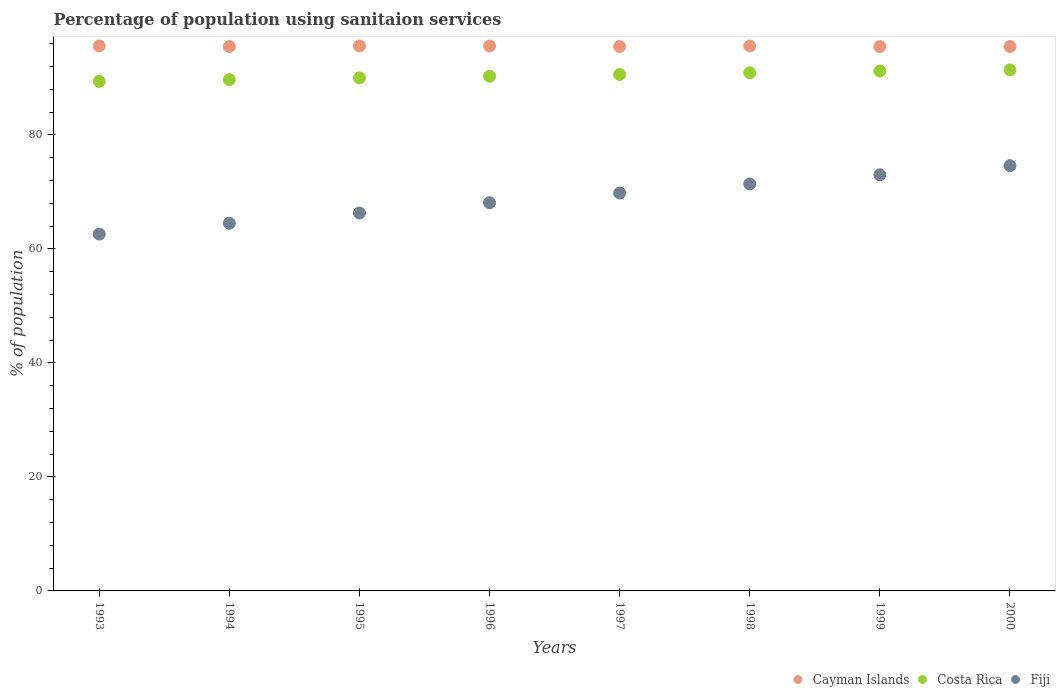Is the number of dotlines equal to the number of legend labels?
Keep it short and to the point. Yes. What is the percentage of population using sanitaion services in Cayman Islands in 1997?
Give a very brief answer. 95.5. Across all years, what is the maximum percentage of population using sanitaion services in Costa Rica?
Give a very brief answer. 91.4. Across all years, what is the minimum percentage of population using sanitaion services in Cayman Islands?
Keep it short and to the point. 95.5. In which year was the percentage of population using sanitaion services in Cayman Islands maximum?
Give a very brief answer. 1993. In which year was the percentage of population using sanitaion services in Fiji minimum?
Make the answer very short. 1993. What is the total percentage of population using sanitaion services in Fiji in the graph?
Your response must be concise. 550.3. What is the difference between the percentage of population using sanitaion services in Cayman Islands in 1996 and that in 1997?
Provide a succinct answer. 0.1. What is the difference between the percentage of population using sanitaion services in Fiji in 1993 and the percentage of population using sanitaion services in Cayman Islands in 1995?
Give a very brief answer. -33. What is the average percentage of population using sanitaion services in Costa Rica per year?
Provide a succinct answer. 90.44. In the year 1993, what is the difference between the percentage of population using sanitaion services in Cayman Islands and percentage of population using sanitaion services in Costa Rica?
Offer a terse response. 6.2. What is the ratio of the percentage of population using sanitaion services in Cayman Islands in 1995 to that in 1997?
Provide a short and direct response. 1. Is the percentage of population using sanitaion services in Cayman Islands in 1993 less than that in 1995?
Give a very brief answer. No. What is the difference between the highest and the second highest percentage of population using sanitaion services in Fiji?
Make the answer very short. 1.6. What is the difference between the highest and the lowest percentage of population using sanitaion services in Fiji?
Your answer should be very brief. 12. Is the sum of the percentage of population using sanitaion services in Cayman Islands in 1993 and 1996 greater than the maximum percentage of population using sanitaion services in Fiji across all years?
Ensure brevity in your answer.  Yes. Is the percentage of population using sanitaion services in Cayman Islands strictly less than the percentage of population using sanitaion services in Fiji over the years?
Give a very brief answer. No. How many dotlines are there?
Offer a terse response. 3. What is the difference between two consecutive major ticks on the Y-axis?
Provide a succinct answer. 20. Does the graph contain any zero values?
Your response must be concise. No. Does the graph contain grids?
Provide a succinct answer. No. Where does the legend appear in the graph?
Your response must be concise. Bottom right. How many legend labels are there?
Offer a very short reply. 3. What is the title of the graph?
Offer a terse response. Percentage of population using sanitaion services. What is the label or title of the Y-axis?
Keep it short and to the point. % of population. What is the % of population in Cayman Islands in 1993?
Offer a terse response. 95.6. What is the % of population in Costa Rica in 1993?
Your answer should be compact. 89.4. What is the % of population in Fiji in 1993?
Offer a terse response. 62.6. What is the % of population of Cayman Islands in 1994?
Make the answer very short. 95.5. What is the % of population in Costa Rica in 1994?
Provide a short and direct response. 89.7. What is the % of population of Fiji in 1994?
Make the answer very short. 64.5. What is the % of population in Cayman Islands in 1995?
Your answer should be compact. 95.6. What is the % of population in Fiji in 1995?
Keep it short and to the point. 66.3. What is the % of population in Cayman Islands in 1996?
Make the answer very short. 95.6. What is the % of population of Costa Rica in 1996?
Give a very brief answer. 90.3. What is the % of population of Fiji in 1996?
Offer a terse response. 68.1. What is the % of population of Cayman Islands in 1997?
Offer a very short reply. 95.5. What is the % of population in Costa Rica in 1997?
Your response must be concise. 90.6. What is the % of population of Fiji in 1997?
Provide a succinct answer. 69.8. What is the % of population of Cayman Islands in 1998?
Make the answer very short. 95.6. What is the % of population of Costa Rica in 1998?
Offer a terse response. 90.9. What is the % of population in Fiji in 1998?
Offer a very short reply. 71.4. What is the % of population of Cayman Islands in 1999?
Your response must be concise. 95.5. What is the % of population in Costa Rica in 1999?
Your answer should be compact. 91.2. What is the % of population in Cayman Islands in 2000?
Offer a very short reply. 95.5. What is the % of population in Costa Rica in 2000?
Your answer should be very brief. 91.4. What is the % of population in Fiji in 2000?
Provide a succinct answer. 74.6. Across all years, what is the maximum % of population of Cayman Islands?
Provide a succinct answer. 95.6. Across all years, what is the maximum % of population of Costa Rica?
Your answer should be compact. 91.4. Across all years, what is the maximum % of population of Fiji?
Provide a succinct answer. 74.6. Across all years, what is the minimum % of population in Cayman Islands?
Your response must be concise. 95.5. Across all years, what is the minimum % of population of Costa Rica?
Keep it short and to the point. 89.4. Across all years, what is the minimum % of population in Fiji?
Ensure brevity in your answer.  62.6. What is the total % of population in Cayman Islands in the graph?
Give a very brief answer. 764.4. What is the total % of population in Costa Rica in the graph?
Provide a succinct answer. 723.5. What is the total % of population of Fiji in the graph?
Offer a terse response. 550.3. What is the difference between the % of population in Cayman Islands in 1993 and that in 1994?
Make the answer very short. 0.1. What is the difference between the % of population of Costa Rica in 1993 and that in 1995?
Your response must be concise. -0.6. What is the difference between the % of population in Cayman Islands in 1993 and that in 1996?
Keep it short and to the point. 0. What is the difference between the % of population of Cayman Islands in 1993 and that in 1997?
Give a very brief answer. 0.1. What is the difference between the % of population of Cayman Islands in 1993 and that in 1998?
Offer a terse response. 0. What is the difference between the % of population of Fiji in 1993 and that in 1998?
Offer a very short reply. -8.8. What is the difference between the % of population in Fiji in 1993 and that in 1999?
Provide a short and direct response. -10.4. What is the difference between the % of population of Fiji in 1993 and that in 2000?
Offer a very short reply. -12. What is the difference between the % of population in Costa Rica in 1994 and that in 1995?
Offer a terse response. -0.3. What is the difference between the % of population of Cayman Islands in 1994 and that in 1996?
Keep it short and to the point. -0.1. What is the difference between the % of population in Fiji in 1994 and that in 1996?
Your response must be concise. -3.6. What is the difference between the % of population of Costa Rica in 1994 and that in 1997?
Ensure brevity in your answer.  -0.9. What is the difference between the % of population in Fiji in 1994 and that in 1997?
Your answer should be very brief. -5.3. What is the difference between the % of population in Cayman Islands in 1994 and that in 1998?
Give a very brief answer. -0.1. What is the difference between the % of population in Costa Rica in 1994 and that in 1998?
Provide a short and direct response. -1.2. What is the difference between the % of population in Fiji in 1994 and that in 1998?
Your answer should be compact. -6.9. What is the difference between the % of population of Cayman Islands in 1994 and that in 1999?
Keep it short and to the point. 0. What is the difference between the % of population in Costa Rica in 1994 and that in 1999?
Make the answer very short. -1.5. What is the difference between the % of population in Fiji in 1994 and that in 1999?
Your answer should be very brief. -8.5. What is the difference between the % of population of Cayman Islands in 1994 and that in 2000?
Offer a terse response. 0. What is the difference between the % of population of Fiji in 1994 and that in 2000?
Your answer should be very brief. -10.1. What is the difference between the % of population of Cayman Islands in 1995 and that in 1996?
Ensure brevity in your answer.  0. What is the difference between the % of population in Costa Rica in 1995 and that in 1996?
Make the answer very short. -0.3. What is the difference between the % of population in Fiji in 1995 and that in 1996?
Offer a very short reply. -1.8. What is the difference between the % of population of Cayman Islands in 1995 and that in 1997?
Give a very brief answer. 0.1. What is the difference between the % of population in Costa Rica in 1995 and that in 1998?
Offer a terse response. -0.9. What is the difference between the % of population in Fiji in 1995 and that in 1998?
Offer a very short reply. -5.1. What is the difference between the % of population in Cayman Islands in 1995 and that in 1999?
Provide a succinct answer. 0.1. What is the difference between the % of population of Costa Rica in 1995 and that in 1999?
Keep it short and to the point. -1.2. What is the difference between the % of population of Cayman Islands in 1995 and that in 2000?
Provide a short and direct response. 0.1. What is the difference between the % of population in Costa Rica in 1995 and that in 2000?
Provide a short and direct response. -1.4. What is the difference between the % of population of Cayman Islands in 1996 and that in 1997?
Your response must be concise. 0.1. What is the difference between the % of population of Fiji in 1996 and that in 1997?
Offer a terse response. -1.7. What is the difference between the % of population in Cayman Islands in 1996 and that in 1998?
Your answer should be very brief. 0. What is the difference between the % of population in Costa Rica in 1996 and that in 1998?
Your answer should be very brief. -0.6. What is the difference between the % of population of Costa Rica in 1996 and that in 1999?
Your answer should be compact. -0.9. What is the difference between the % of population of Fiji in 1996 and that in 1999?
Give a very brief answer. -4.9. What is the difference between the % of population in Fiji in 1996 and that in 2000?
Make the answer very short. -6.5. What is the difference between the % of population of Costa Rica in 1997 and that in 1998?
Provide a succinct answer. -0.3. What is the difference between the % of population of Fiji in 1997 and that in 1998?
Your answer should be very brief. -1.6. What is the difference between the % of population of Costa Rica in 1997 and that in 1999?
Provide a succinct answer. -0.6. What is the difference between the % of population in Fiji in 1997 and that in 1999?
Your answer should be very brief. -3.2. What is the difference between the % of population of Costa Rica in 1997 and that in 2000?
Your answer should be very brief. -0.8. What is the difference between the % of population in Fiji in 1997 and that in 2000?
Provide a short and direct response. -4.8. What is the difference between the % of population in Cayman Islands in 1998 and that in 2000?
Provide a succinct answer. 0.1. What is the difference between the % of population in Costa Rica in 1998 and that in 2000?
Make the answer very short. -0.5. What is the difference between the % of population of Costa Rica in 1999 and that in 2000?
Provide a short and direct response. -0.2. What is the difference between the % of population in Cayman Islands in 1993 and the % of population in Fiji in 1994?
Make the answer very short. 31.1. What is the difference between the % of population in Costa Rica in 1993 and the % of population in Fiji in 1994?
Offer a terse response. 24.9. What is the difference between the % of population of Cayman Islands in 1993 and the % of population of Costa Rica in 1995?
Your response must be concise. 5.6. What is the difference between the % of population of Cayman Islands in 1993 and the % of population of Fiji in 1995?
Make the answer very short. 29.3. What is the difference between the % of population in Costa Rica in 1993 and the % of population in Fiji in 1995?
Your answer should be compact. 23.1. What is the difference between the % of population of Costa Rica in 1993 and the % of population of Fiji in 1996?
Ensure brevity in your answer.  21.3. What is the difference between the % of population in Cayman Islands in 1993 and the % of population in Fiji in 1997?
Provide a short and direct response. 25.8. What is the difference between the % of population of Costa Rica in 1993 and the % of population of Fiji in 1997?
Give a very brief answer. 19.6. What is the difference between the % of population in Cayman Islands in 1993 and the % of population in Costa Rica in 1998?
Provide a short and direct response. 4.7. What is the difference between the % of population of Cayman Islands in 1993 and the % of population of Fiji in 1998?
Keep it short and to the point. 24.2. What is the difference between the % of population of Cayman Islands in 1993 and the % of population of Fiji in 1999?
Your response must be concise. 22.6. What is the difference between the % of population in Cayman Islands in 1993 and the % of population in Costa Rica in 2000?
Offer a very short reply. 4.2. What is the difference between the % of population of Cayman Islands in 1994 and the % of population of Fiji in 1995?
Give a very brief answer. 29.2. What is the difference between the % of population of Costa Rica in 1994 and the % of population of Fiji in 1995?
Offer a terse response. 23.4. What is the difference between the % of population in Cayman Islands in 1994 and the % of population in Fiji in 1996?
Provide a succinct answer. 27.4. What is the difference between the % of population in Costa Rica in 1994 and the % of population in Fiji in 1996?
Your answer should be compact. 21.6. What is the difference between the % of population of Cayman Islands in 1994 and the % of population of Costa Rica in 1997?
Your answer should be very brief. 4.9. What is the difference between the % of population of Cayman Islands in 1994 and the % of population of Fiji in 1997?
Offer a terse response. 25.7. What is the difference between the % of population in Costa Rica in 1994 and the % of population in Fiji in 1997?
Your answer should be very brief. 19.9. What is the difference between the % of population of Cayman Islands in 1994 and the % of population of Costa Rica in 1998?
Your answer should be very brief. 4.6. What is the difference between the % of population of Cayman Islands in 1994 and the % of population of Fiji in 1998?
Ensure brevity in your answer.  24.1. What is the difference between the % of population of Cayman Islands in 1994 and the % of population of Costa Rica in 1999?
Give a very brief answer. 4.3. What is the difference between the % of population in Cayman Islands in 1994 and the % of population in Fiji in 1999?
Offer a very short reply. 22.5. What is the difference between the % of population in Costa Rica in 1994 and the % of population in Fiji in 1999?
Make the answer very short. 16.7. What is the difference between the % of population in Cayman Islands in 1994 and the % of population in Costa Rica in 2000?
Provide a short and direct response. 4.1. What is the difference between the % of population of Cayman Islands in 1994 and the % of population of Fiji in 2000?
Provide a succinct answer. 20.9. What is the difference between the % of population of Cayman Islands in 1995 and the % of population of Fiji in 1996?
Your answer should be compact. 27.5. What is the difference between the % of population in Costa Rica in 1995 and the % of population in Fiji in 1996?
Ensure brevity in your answer.  21.9. What is the difference between the % of population of Cayman Islands in 1995 and the % of population of Costa Rica in 1997?
Provide a short and direct response. 5. What is the difference between the % of population of Cayman Islands in 1995 and the % of population of Fiji in 1997?
Make the answer very short. 25.8. What is the difference between the % of population of Costa Rica in 1995 and the % of population of Fiji in 1997?
Provide a succinct answer. 20.2. What is the difference between the % of population in Cayman Islands in 1995 and the % of population in Fiji in 1998?
Give a very brief answer. 24.2. What is the difference between the % of population in Costa Rica in 1995 and the % of population in Fiji in 1998?
Make the answer very short. 18.6. What is the difference between the % of population of Cayman Islands in 1995 and the % of population of Fiji in 1999?
Keep it short and to the point. 22.6. What is the difference between the % of population in Costa Rica in 1995 and the % of population in Fiji in 2000?
Your answer should be compact. 15.4. What is the difference between the % of population of Cayman Islands in 1996 and the % of population of Costa Rica in 1997?
Give a very brief answer. 5. What is the difference between the % of population in Cayman Islands in 1996 and the % of population in Fiji in 1997?
Give a very brief answer. 25.8. What is the difference between the % of population of Costa Rica in 1996 and the % of population of Fiji in 1997?
Offer a very short reply. 20.5. What is the difference between the % of population of Cayman Islands in 1996 and the % of population of Fiji in 1998?
Give a very brief answer. 24.2. What is the difference between the % of population in Costa Rica in 1996 and the % of population in Fiji in 1998?
Your answer should be very brief. 18.9. What is the difference between the % of population of Cayman Islands in 1996 and the % of population of Costa Rica in 1999?
Offer a terse response. 4.4. What is the difference between the % of population of Cayman Islands in 1996 and the % of population of Fiji in 1999?
Offer a very short reply. 22.6. What is the difference between the % of population in Costa Rica in 1996 and the % of population in Fiji in 1999?
Your answer should be very brief. 17.3. What is the difference between the % of population in Cayman Islands in 1996 and the % of population in Costa Rica in 2000?
Provide a short and direct response. 4.2. What is the difference between the % of population in Costa Rica in 1996 and the % of population in Fiji in 2000?
Offer a terse response. 15.7. What is the difference between the % of population of Cayman Islands in 1997 and the % of population of Fiji in 1998?
Keep it short and to the point. 24.1. What is the difference between the % of population of Costa Rica in 1997 and the % of population of Fiji in 1998?
Your answer should be compact. 19.2. What is the difference between the % of population in Cayman Islands in 1997 and the % of population in Costa Rica in 1999?
Your answer should be compact. 4.3. What is the difference between the % of population of Costa Rica in 1997 and the % of population of Fiji in 1999?
Your response must be concise. 17.6. What is the difference between the % of population in Cayman Islands in 1997 and the % of population in Costa Rica in 2000?
Provide a succinct answer. 4.1. What is the difference between the % of population in Cayman Islands in 1997 and the % of population in Fiji in 2000?
Your response must be concise. 20.9. What is the difference between the % of population in Costa Rica in 1997 and the % of population in Fiji in 2000?
Provide a succinct answer. 16. What is the difference between the % of population of Cayman Islands in 1998 and the % of population of Fiji in 1999?
Offer a terse response. 22.6. What is the difference between the % of population of Costa Rica in 1998 and the % of population of Fiji in 1999?
Your response must be concise. 17.9. What is the difference between the % of population of Cayman Islands in 1998 and the % of population of Costa Rica in 2000?
Ensure brevity in your answer.  4.2. What is the difference between the % of population in Cayman Islands in 1998 and the % of population in Fiji in 2000?
Provide a short and direct response. 21. What is the difference between the % of population in Cayman Islands in 1999 and the % of population in Fiji in 2000?
Your answer should be very brief. 20.9. What is the average % of population in Cayman Islands per year?
Keep it short and to the point. 95.55. What is the average % of population in Costa Rica per year?
Your answer should be very brief. 90.44. What is the average % of population of Fiji per year?
Your answer should be very brief. 68.79. In the year 1993, what is the difference between the % of population of Costa Rica and % of population of Fiji?
Provide a short and direct response. 26.8. In the year 1994, what is the difference between the % of population of Costa Rica and % of population of Fiji?
Make the answer very short. 25.2. In the year 1995, what is the difference between the % of population of Cayman Islands and % of population of Fiji?
Offer a terse response. 29.3. In the year 1995, what is the difference between the % of population in Costa Rica and % of population in Fiji?
Your answer should be compact. 23.7. In the year 1996, what is the difference between the % of population in Cayman Islands and % of population in Fiji?
Offer a very short reply. 27.5. In the year 1997, what is the difference between the % of population of Cayman Islands and % of population of Fiji?
Your response must be concise. 25.7. In the year 1997, what is the difference between the % of population of Costa Rica and % of population of Fiji?
Provide a succinct answer. 20.8. In the year 1998, what is the difference between the % of population of Cayman Islands and % of population of Fiji?
Provide a succinct answer. 24.2. In the year 1998, what is the difference between the % of population in Costa Rica and % of population in Fiji?
Your answer should be compact. 19.5. In the year 2000, what is the difference between the % of population in Cayman Islands and % of population in Fiji?
Keep it short and to the point. 20.9. In the year 2000, what is the difference between the % of population of Costa Rica and % of population of Fiji?
Keep it short and to the point. 16.8. What is the ratio of the % of population of Cayman Islands in 1993 to that in 1994?
Keep it short and to the point. 1. What is the ratio of the % of population of Costa Rica in 1993 to that in 1994?
Ensure brevity in your answer.  1. What is the ratio of the % of population in Fiji in 1993 to that in 1994?
Provide a short and direct response. 0.97. What is the ratio of the % of population in Cayman Islands in 1993 to that in 1995?
Keep it short and to the point. 1. What is the ratio of the % of population in Fiji in 1993 to that in 1995?
Your answer should be very brief. 0.94. What is the ratio of the % of population of Costa Rica in 1993 to that in 1996?
Your answer should be very brief. 0.99. What is the ratio of the % of population in Fiji in 1993 to that in 1996?
Provide a succinct answer. 0.92. What is the ratio of the % of population of Cayman Islands in 1993 to that in 1997?
Ensure brevity in your answer.  1. What is the ratio of the % of population in Fiji in 1993 to that in 1997?
Your answer should be very brief. 0.9. What is the ratio of the % of population of Costa Rica in 1993 to that in 1998?
Your answer should be compact. 0.98. What is the ratio of the % of population in Fiji in 1993 to that in 1998?
Make the answer very short. 0.88. What is the ratio of the % of population of Costa Rica in 1993 to that in 1999?
Offer a very short reply. 0.98. What is the ratio of the % of population of Fiji in 1993 to that in 1999?
Provide a succinct answer. 0.86. What is the ratio of the % of population in Cayman Islands in 1993 to that in 2000?
Keep it short and to the point. 1. What is the ratio of the % of population in Costa Rica in 1993 to that in 2000?
Your answer should be very brief. 0.98. What is the ratio of the % of population in Fiji in 1993 to that in 2000?
Offer a very short reply. 0.84. What is the ratio of the % of population of Costa Rica in 1994 to that in 1995?
Provide a short and direct response. 1. What is the ratio of the % of population of Fiji in 1994 to that in 1995?
Offer a terse response. 0.97. What is the ratio of the % of population in Costa Rica in 1994 to that in 1996?
Your response must be concise. 0.99. What is the ratio of the % of population of Fiji in 1994 to that in 1996?
Make the answer very short. 0.95. What is the ratio of the % of population in Fiji in 1994 to that in 1997?
Your response must be concise. 0.92. What is the ratio of the % of population of Cayman Islands in 1994 to that in 1998?
Your response must be concise. 1. What is the ratio of the % of population of Costa Rica in 1994 to that in 1998?
Make the answer very short. 0.99. What is the ratio of the % of population of Fiji in 1994 to that in 1998?
Keep it short and to the point. 0.9. What is the ratio of the % of population of Costa Rica in 1994 to that in 1999?
Give a very brief answer. 0.98. What is the ratio of the % of population of Fiji in 1994 to that in 1999?
Provide a short and direct response. 0.88. What is the ratio of the % of population in Costa Rica in 1994 to that in 2000?
Make the answer very short. 0.98. What is the ratio of the % of population in Fiji in 1994 to that in 2000?
Provide a succinct answer. 0.86. What is the ratio of the % of population in Cayman Islands in 1995 to that in 1996?
Provide a short and direct response. 1. What is the ratio of the % of population in Costa Rica in 1995 to that in 1996?
Make the answer very short. 1. What is the ratio of the % of population of Fiji in 1995 to that in 1996?
Your response must be concise. 0.97. What is the ratio of the % of population in Cayman Islands in 1995 to that in 1997?
Offer a terse response. 1. What is the ratio of the % of population of Fiji in 1995 to that in 1997?
Offer a terse response. 0.95. What is the ratio of the % of population in Cayman Islands in 1995 to that in 1998?
Provide a succinct answer. 1. What is the ratio of the % of population of Fiji in 1995 to that in 1998?
Offer a terse response. 0.93. What is the ratio of the % of population in Cayman Islands in 1995 to that in 1999?
Your response must be concise. 1. What is the ratio of the % of population of Costa Rica in 1995 to that in 1999?
Provide a succinct answer. 0.99. What is the ratio of the % of population of Fiji in 1995 to that in 1999?
Offer a terse response. 0.91. What is the ratio of the % of population of Costa Rica in 1995 to that in 2000?
Keep it short and to the point. 0.98. What is the ratio of the % of population in Fiji in 1995 to that in 2000?
Offer a terse response. 0.89. What is the ratio of the % of population in Costa Rica in 1996 to that in 1997?
Your answer should be compact. 1. What is the ratio of the % of population in Fiji in 1996 to that in 1997?
Your answer should be compact. 0.98. What is the ratio of the % of population of Cayman Islands in 1996 to that in 1998?
Your response must be concise. 1. What is the ratio of the % of population in Fiji in 1996 to that in 1998?
Give a very brief answer. 0.95. What is the ratio of the % of population in Fiji in 1996 to that in 1999?
Provide a succinct answer. 0.93. What is the ratio of the % of population of Cayman Islands in 1996 to that in 2000?
Ensure brevity in your answer.  1. What is the ratio of the % of population of Costa Rica in 1996 to that in 2000?
Your answer should be very brief. 0.99. What is the ratio of the % of population in Fiji in 1996 to that in 2000?
Keep it short and to the point. 0.91. What is the ratio of the % of population of Cayman Islands in 1997 to that in 1998?
Offer a very short reply. 1. What is the ratio of the % of population of Fiji in 1997 to that in 1998?
Offer a very short reply. 0.98. What is the ratio of the % of population of Fiji in 1997 to that in 1999?
Keep it short and to the point. 0.96. What is the ratio of the % of population of Fiji in 1997 to that in 2000?
Your answer should be very brief. 0.94. What is the ratio of the % of population of Cayman Islands in 1998 to that in 1999?
Ensure brevity in your answer.  1. What is the ratio of the % of population of Fiji in 1998 to that in 1999?
Ensure brevity in your answer.  0.98. What is the ratio of the % of population in Cayman Islands in 1998 to that in 2000?
Your response must be concise. 1. What is the ratio of the % of population in Fiji in 1998 to that in 2000?
Your response must be concise. 0.96. What is the ratio of the % of population of Cayman Islands in 1999 to that in 2000?
Provide a short and direct response. 1. What is the ratio of the % of population of Fiji in 1999 to that in 2000?
Give a very brief answer. 0.98. What is the difference between the highest and the second highest % of population in Cayman Islands?
Your answer should be very brief. 0. What is the difference between the highest and the second highest % of population of Costa Rica?
Make the answer very short. 0.2. What is the difference between the highest and the lowest % of population in Costa Rica?
Offer a very short reply. 2. 